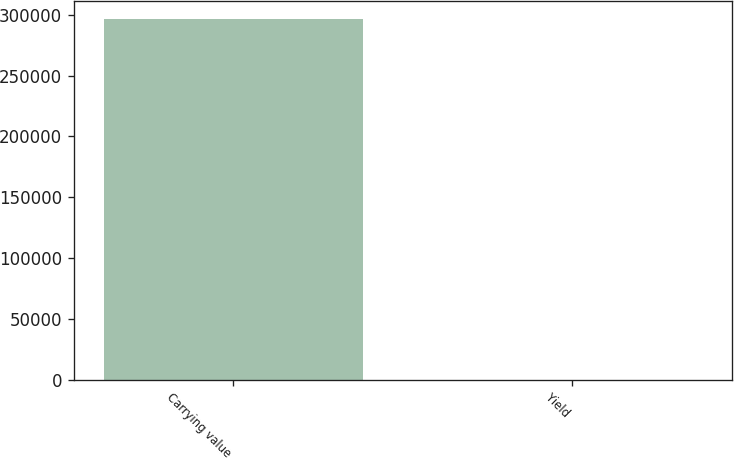Convert chart. <chart><loc_0><loc_0><loc_500><loc_500><bar_chart><fcel>Carrying value<fcel>Yield<nl><fcel>296713<fcel>3.71<nl></chart> 